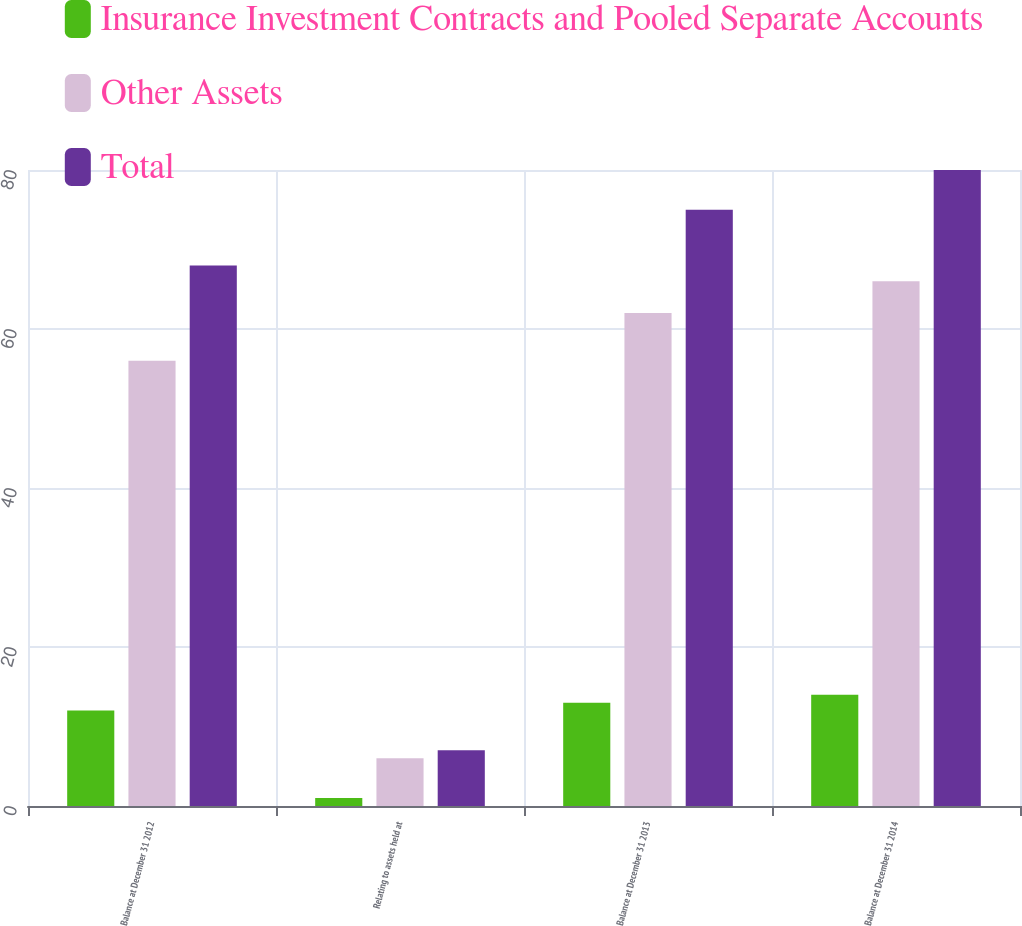Convert chart. <chart><loc_0><loc_0><loc_500><loc_500><stacked_bar_chart><ecel><fcel>Balance at December 31 2012<fcel>Relating to assets held at<fcel>Balance at December 31 2013<fcel>Balance at December 31 2014<nl><fcel>Insurance Investment Contracts and Pooled Separate Accounts<fcel>12<fcel>1<fcel>13<fcel>14<nl><fcel>Other Assets<fcel>56<fcel>6<fcel>62<fcel>66<nl><fcel>Total<fcel>68<fcel>7<fcel>75<fcel>80<nl></chart> 